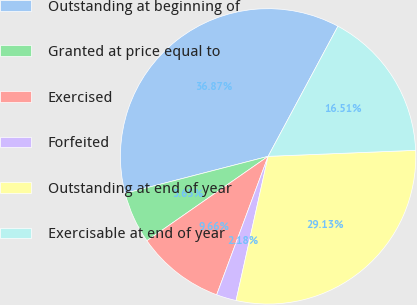Convert chart. <chart><loc_0><loc_0><loc_500><loc_500><pie_chart><fcel>Outstanding at beginning of<fcel>Granted at price equal to<fcel>Exercised<fcel>Forfeited<fcel>Outstanding at end of year<fcel>Exercisable at end of year<nl><fcel>36.87%<fcel>5.65%<fcel>9.66%<fcel>2.18%<fcel>29.13%<fcel>16.51%<nl></chart> 